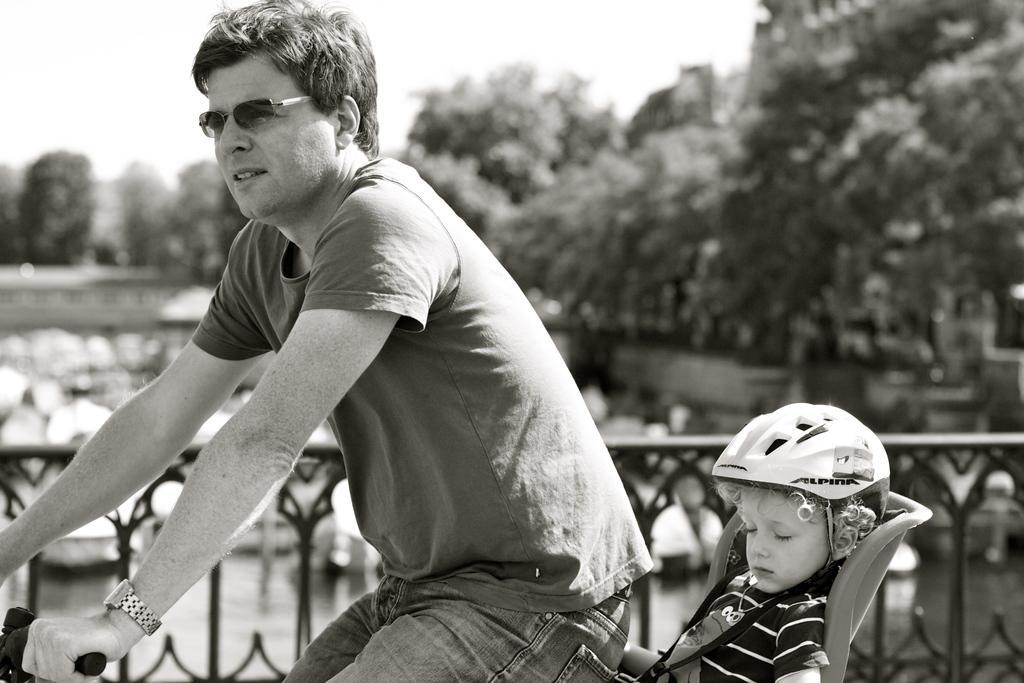Please provide a concise description of this image. In this picture there is a man sitting on the bicycle and there is a boy sitting on the bicycle. At the back there is a railing and there are boats on the water and there are trees. At the top there is sky. At the bottom there is water. 